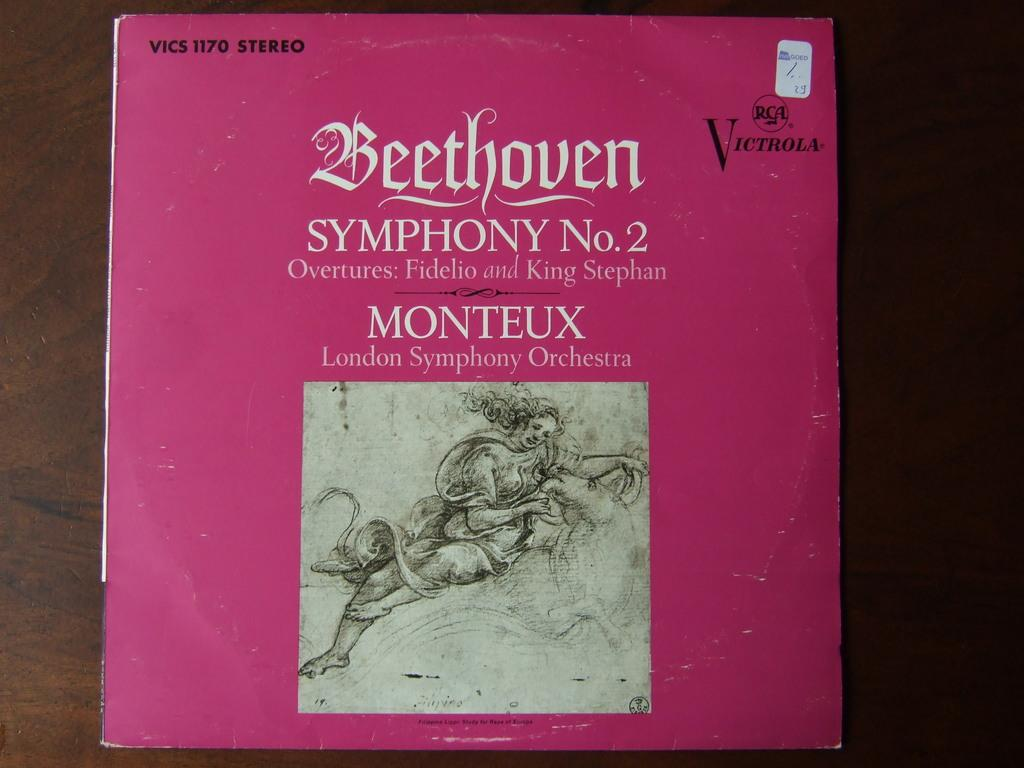<image>
Present a compact description of the photo's key features. The Victrola record cover sleeve of Beethoven's Symphony No 2. 